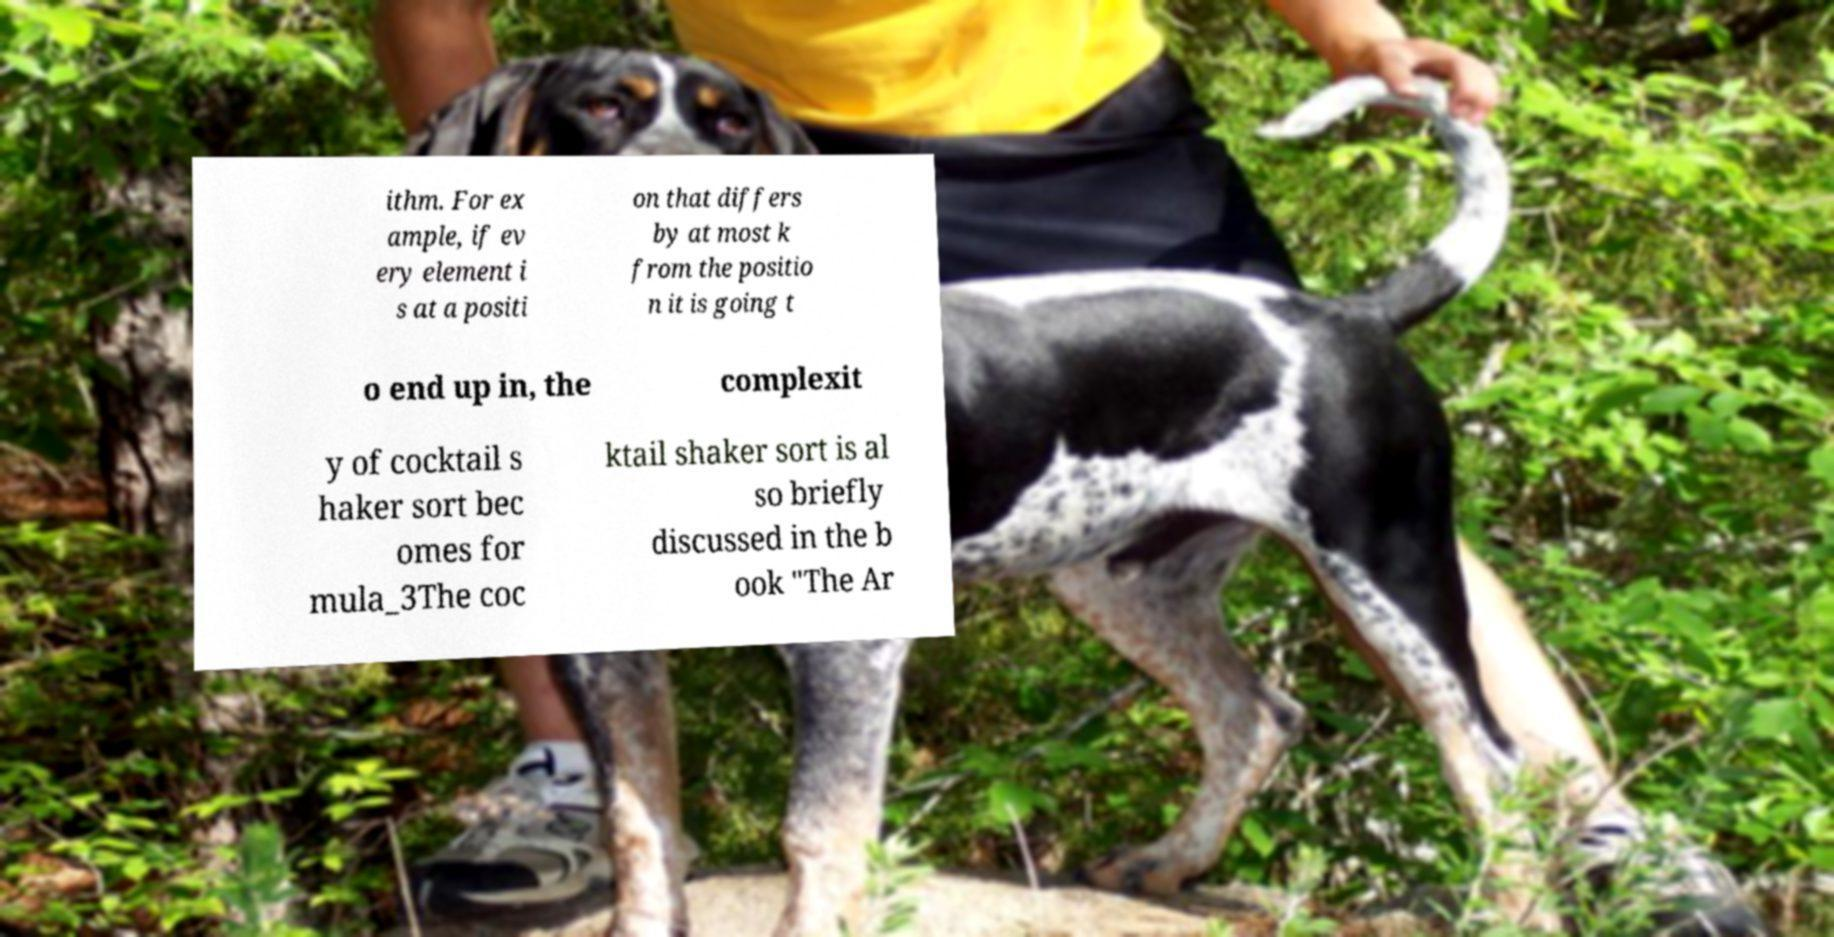What messages or text are displayed in this image? I need them in a readable, typed format. ithm. For ex ample, if ev ery element i s at a positi on that differs by at most k from the positio n it is going t o end up in, the complexit y of cocktail s haker sort bec omes for mula_3The coc ktail shaker sort is al so briefly discussed in the b ook "The Ar 